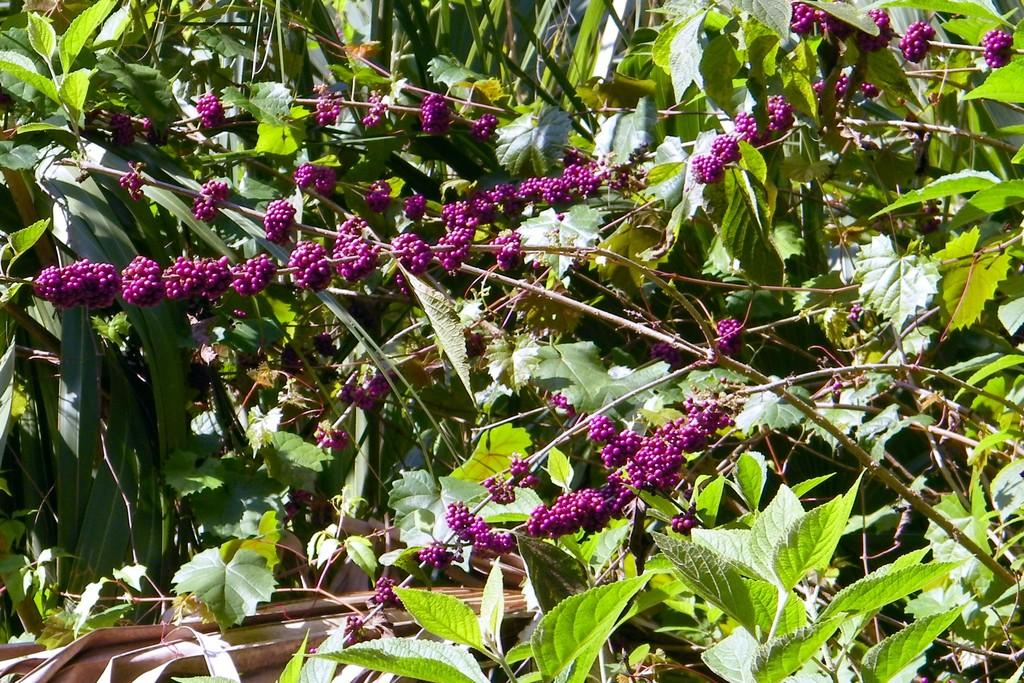What is the main subject of the image? The main subject of the image is a group of plants. What can be observed on the plants? There are fruit buds on the plants. What is the color of the fruit buds? The fruit buds are dark pink in color. What type of brass instrument can be heard playing in the background of the image? There is a brass instrument, but there is no brass instrument or sound in the image. 